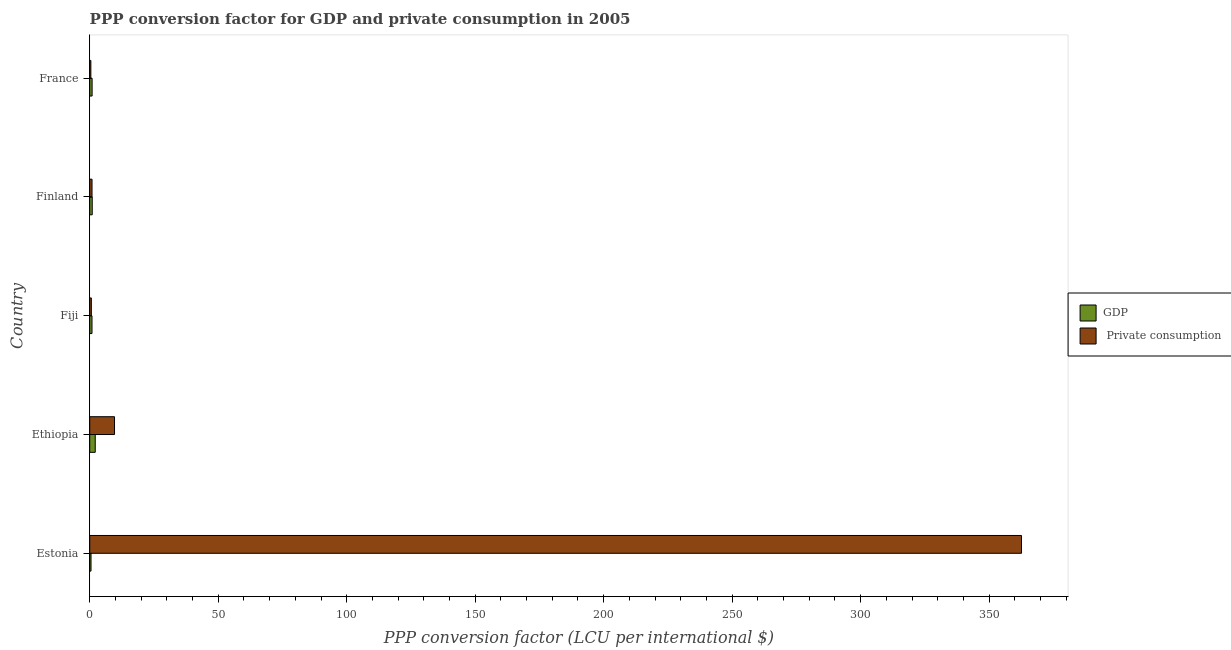How many different coloured bars are there?
Provide a short and direct response. 2. How many groups of bars are there?
Your response must be concise. 5. Are the number of bars on each tick of the Y-axis equal?
Offer a terse response. Yes. How many bars are there on the 3rd tick from the top?
Make the answer very short. 2. How many bars are there on the 1st tick from the bottom?
Give a very brief answer. 2. What is the label of the 2nd group of bars from the top?
Your response must be concise. Finland. In how many cases, is the number of bars for a given country not equal to the number of legend labels?
Provide a short and direct response. 0. What is the ppp conversion factor for private consumption in Estonia?
Provide a succinct answer. 362.59. Across all countries, what is the maximum ppp conversion factor for private consumption?
Offer a terse response. 362.59. Across all countries, what is the minimum ppp conversion factor for private consumption?
Ensure brevity in your answer.  0.44. In which country was the ppp conversion factor for private consumption maximum?
Ensure brevity in your answer.  Estonia. In which country was the ppp conversion factor for private consumption minimum?
Provide a short and direct response. France. What is the total ppp conversion factor for private consumption in the graph?
Your response must be concise. 374.2. What is the difference between the ppp conversion factor for gdp in Estonia and that in Finland?
Your response must be concise. -0.47. What is the difference between the ppp conversion factor for private consumption in Finland and the ppp conversion factor for gdp in France?
Your response must be concise. -0.03. What is the average ppp conversion factor for private consumption per country?
Your answer should be very brief. 74.84. What is the difference between the ppp conversion factor for gdp and ppp conversion factor for private consumption in Estonia?
Your answer should be compact. -362.09. What is the ratio of the ppp conversion factor for private consumption in Ethiopia to that in Finland?
Your response must be concise. 10.75. Is the ppp conversion factor for gdp in Estonia less than that in Ethiopia?
Ensure brevity in your answer.  Yes. Is the difference between the ppp conversion factor for private consumption in Ethiopia and Finland greater than the difference between the ppp conversion factor for gdp in Ethiopia and Finland?
Your answer should be very brief. Yes. What is the difference between the highest and the second highest ppp conversion factor for private consumption?
Provide a succinct answer. 352.94. What is the difference between the highest and the lowest ppp conversion factor for private consumption?
Ensure brevity in your answer.  362.15. What does the 1st bar from the top in France represents?
Your response must be concise.  Private consumption. What does the 2nd bar from the bottom in Estonia represents?
Provide a succinct answer.  Private consumption. How many bars are there?
Ensure brevity in your answer.  10. How many countries are there in the graph?
Provide a succinct answer. 5. What is the difference between two consecutive major ticks on the X-axis?
Keep it short and to the point. 50. Are the values on the major ticks of X-axis written in scientific E-notation?
Provide a short and direct response. No. Does the graph contain any zero values?
Provide a short and direct response. No. Does the graph contain grids?
Offer a very short reply. No. Where does the legend appear in the graph?
Offer a very short reply. Center right. What is the title of the graph?
Your answer should be compact. PPP conversion factor for GDP and private consumption in 2005. Does "Underweight" appear as one of the legend labels in the graph?
Give a very brief answer. No. What is the label or title of the X-axis?
Give a very brief answer. PPP conversion factor (LCU per international $). What is the label or title of the Y-axis?
Offer a terse response. Country. What is the PPP conversion factor (LCU per international $) of GDP in Estonia?
Provide a succinct answer. 0.5. What is the PPP conversion factor (LCU per international $) in  Private consumption in Estonia?
Offer a very short reply. 362.59. What is the PPP conversion factor (LCU per international $) of GDP in Ethiopia?
Ensure brevity in your answer.  2.14. What is the PPP conversion factor (LCU per international $) in  Private consumption in Ethiopia?
Provide a succinct answer. 9.65. What is the PPP conversion factor (LCU per international $) in GDP in Fiji?
Ensure brevity in your answer.  0.88. What is the PPP conversion factor (LCU per international $) of  Private consumption in Fiji?
Provide a short and direct response. 0.63. What is the PPP conversion factor (LCU per international $) of GDP in Finland?
Your answer should be compact. 0.98. What is the PPP conversion factor (LCU per international $) in  Private consumption in Finland?
Offer a terse response. 0.9. What is the PPP conversion factor (LCU per international $) of GDP in France?
Provide a succinct answer. 0.92. What is the PPP conversion factor (LCU per international $) of  Private consumption in France?
Provide a short and direct response. 0.44. Across all countries, what is the maximum PPP conversion factor (LCU per international $) in GDP?
Offer a very short reply. 2.14. Across all countries, what is the maximum PPP conversion factor (LCU per international $) of  Private consumption?
Provide a short and direct response. 362.59. Across all countries, what is the minimum PPP conversion factor (LCU per international $) of GDP?
Your response must be concise. 0.5. Across all countries, what is the minimum PPP conversion factor (LCU per international $) in  Private consumption?
Provide a succinct answer. 0.44. What is the total PPP conversion factor (LCU per international $) of GDP in the graph?
Your answer should be compact. 5.43. What is the total PPP conversion factor (LCU per international $) in  Private consumption in the graph?
Keep it short and to the point. 374.2. What is the difference between the PPP conversion factor (LCU per international $) of GDP in Estonia and that in Ethiopia?
Keep it short and to the point. -1.64. What is the difference between the PPP conversion factor (LCU per international $) in  Private consumption in Estonia and that in Ethiopia?
Offer a terse response. 352.94. What is the difference between the PPP conversion factor (LCU per international $) of GDP in Estonia and that in Fiji?
Make the answer very short. -0.38. What is the difference between the PPP conversion factor (LCU per international $) in  Private consumption in Estonia and that in Fiji?
Your answer should be very brief. 361.97. What is the difference between the PPP conversion factor (LCU per international $) of GDP in Estonia and that in Finland?
Keep it short and to the point. -0.48. What is the difference between the PPP conversion factor (LCU per international $) in  Private consumption in Estonia and that in Finland?
Give a very brief answer. 361.69. What is the difference between the PPP conversion factor (LCU per international $) of GDP in Estonia and that in France?
Make the answer very short. -0.42. What is the difference between the PPP conversion factor (LCU per international $) of  Private consumption in Estonia and that in France?
Ensure brevity in your answer.  362.15. What is the difference between the PPP conversion factor (LCU per international $) in GDP in Ethiopia and that in Fiji?
Provide a succinct answer. 1.26. What is the difference between the PPP conversion factor (LCU per international $) of  Private consumption in Ethiopia and that in Fiji?
Offer a very short reply. 9.02. What is the difference between the PPP conversion factor (LCU per international $) in GDP in Ethiopia and that in Finland?
Provide a succinct answer. 1.17. What is the difference between the PPP conversion factor (LCU per international $) of  Private consumption in Ethiopia and that in Finland?
Give a very brief answer. 8.75. What is the difference between the PPP conversion factor (LCU per international $) of GDP in Ethiopia and that in France?
Provide a succinct answer. 1.22. What is the difference between the PPP conversion factor (LCU per international $) of  Private consumption in Ethiopia and that in France?
Provide a short and direct response. 9.2. What is the difference between the PPP conversion factor (LCU per international $) of GDP in Fiji and that in Finland?
Your answer should be compact. -0.09. What is the difference between the PPP conversion factor (LCU per international $) of  Private consumption in Fiji and that in Finland?
Keep it short and to the point. -0.27. What is the difference between the PPP conversion factor (LCU per international $) of GDP in Fiji and that in France?
Keep it short and to the point. -0.04. What is the difference between the PPP conversion factor (LCU per international $) in  Private consumption in Fiji and that in France?
Your answer should be compact. 0.18. What is the difference between the PPP conversion factor (LCU per international $) in GDP in Finland and that in France?
Give a very brief answer. 0.05. What is the difference between the PPP conversion factor (LCU per international $) in  Private consumption in Finland and that in France?
Provide a succinct answer. 0.46. What is the difference between the PPP conversion factor (LCU per international $) of GDP in Estonia and the PPP conversion factor (LCU per international $) of  Private consumption in Ethiopia?
Give a very brief answer. -9.14. What is the difference between the PPP conversion factor (LCU per international $) of GDP in Estonia and the PPP conversion factor (LCU per international $) of  Private consumption in Fiji?
Provide a succinct answer. -0.12. What is the difference between the PPP conversion factor (LCU per international $) in GDP in Estonia and the PPP conversion factor (LCU per international $) in  Private consumption in Finland?
Your answer should be very brief. -0.39. What is the difference between the PPP conversion factor (LCU per international $) of GDP in Estonia and the PPP conversion factor (LCU per international $) of  Private consumption in France?
Provide a succinct answer. 0.06. What is the difference between the PPP conversion factor (LCU per international $) in GDP in Ethiopia and the PPP conversion factor (LCU per international $) in  Private consumption in Fiji?
Offer a very short reply. 1.52. What is the difference between the PPP conversion factor (LCU per international $) in GDP in Ethiopia and the PPP conversion factor (LCU per international $) in  Private consumption in Finland?
Provide a short and direct response. 1.25. What is the difference between the PPP conversion factor (LCU per international $) in GDP in Ethiopia and the PPP conversion factor (LCU per international $) in  Private consumption in France?
Provide a short and direct response. 1.7. What is the difference between the PPP conversion factor (LCU per international $) in GDP in Fiji and the PPP conversion factor (LCU per international $) in  Private consumption in Finland?
Offer a very short reply. -0.01. What is the difference between the PPP conversion factor (LCU per international $) of GDP in Fiji and the PPP conversion factor (LCU per international $) of  Private consumption in France?
Make the answer very short. 0.44. What is the difference between the PPP conversion factor (LCU per international $) in GDP in Finland and the PPP conversion factor (LCU per international $) in  Private consumption in France?
Your response must be concise. 0.54. What is the average PPP conversion factor (LCU per international $) in GDP per country?
Make the answer very short. 1.09. What is the average PPP conversion factor (LCU per international $) in  Private consumption per country?
Your answer should be very brief. 74.84. What is the difference between the PPP conversion factor (LCU per international $) of GDP and PPP conversion factor (LCU per international $) of  Private consumption in Estonia?
Provide a succinct answer. -362.09. What is the difference between the PPP conversion factor (LCU per international $) in GDP and PPP conversion factor (LCU per international $) in  Private consumption in Ethiopia?
Ensure brevity in your answer.  -7.5. What is the difference between the PPP conversion factor (LCU per international $) in GDP and PPP conversion factor (LCU per international $) in  Private consumption in Fiji?
Give a very brief answer. 0.26. What is the difference between the PPP conversion factor (LCU per international $) in GDP and PPP conversion factor (LCU per international $) in  Private consumption in Finland?
Offer a very short reply. 0.08. What is the difference between the PPP conversion factor (LCU per international $) in GDP and PPP conversion factor (LCU per international $) in  Private consumption in France?
Make the answer very short. 0.48. What is the ratio of the PPP conversion factor (LCU per international $) in GDP in Estonia to that in Ethiopia?
Offer a terse response. 0.23. What is the ratio of the PPP conversion factor (LCU per international $) in  Private consumption in Estonia to that in Ethiopia?
Offer a very short reply. 37.59. What is the ratio of the PPP conversion factor (LCU per international $) in GDP in Estonia to that in Fiji?
Your answer should be very brief. 0.57. What is the ratio of the PPP conversion factor (LCU per international $) of  Private consumption in Estonia to that in Fiji?
Your answer should be compact. 580.1. What is the ratio of the PPP conversion factor (LCU per international $) of GDP in Estonia to that in Finland?
Your answer should be very brief. 0.51. What is the ratio of the PPP conversion factor (LCU per international $) in  Private consumption in Estonia to that in Finland?
Your answer should be compact. 404.27. What is the ratio of the PPP conversion factor (LCU per international $) in GDP in Estonia to that in France?
Keep it short and to the point. 0.54. What is the ratio of the PPP conversion factor (LCU per international $) of  Private consumption in Estonia to that in France?
Offer a terse response. 820.63. What is the ratio of the PPP conversion factor (LCU per international $) in GDP in Ethiopia to that in Fiji?
Make the answer very short. 2.43. What is the ratio of the PPP conversion factor (LCU per international $) of  Private consumption in Ethiopia to that in Fiji?
Ensure brevity in your answer.  15.43. What is the ratio of the PPP conversion factor (LCU per international $) of GDP in Ethiopia to that in Finland?
Your answer should be compact. 2.19. What is the ratio of the PPP conversion factor (LCU per international $) in  Private consumption in Ethiopia to that in Finland?
Your answer should be compact. 10.75. What is the ratio of the PPP conversion factor (LCU per international $) in GDP in Ethiopia to that in France?
Give a very brief answer. 2.32. What is the ratio of the PPP conversion factor (LCU per international $) of  Private consumption in Ethiopia to that in France?
Ensure brevity in your answer.  21.83. What is the ratio of the PPP conversion factor (LCU per international $) in GDP in Fiji to that in Finland?
Keep it short and to the point. 0.9. What is the ratio of the PPP conversion factor (LCU per international $) of  Private consumption in Fiji to that in Finland?
Keep it short and to the point. 0.7. What is the ratio of the PPP conversion factor (LCU per international $) of GDP in Fiji to that in France?
Make the answer very short. 0.96. What is the ratio of the PPP conversion factor (LCU per international $) of  Private consumption in Fiji to that in France?
Your answer should be very brief. 1.41. What is the ratio of the PPP conversion factor (LCU per international $) of GDP in Finland to that in France?
Ensure brevity in your answer.  1.06. What is the ratio of the PPP conversion factor (LCU per international $) of  Private consumption in Finland to that in France?
Make the answer very short. 2.03. What is the difference between the highest and the second highest PPP conversion factor (LCU per international $) of GDP?
Your response must be concise. 1.17. What is the difference between the highest and the second highest PPP conversion factor (LCU per international $) of  Private consumption?
Make the answer very short. 352.94. What is the difference between the highest and the lowest PPP conversion factor (LCU per international $) in GDP?
Offer a terse response. 1.64. What is the difference between the highest and the lowest PPP conversion factor (LCU per international $) in  Private consumption?
Provide a succinct answer. 362.15. 